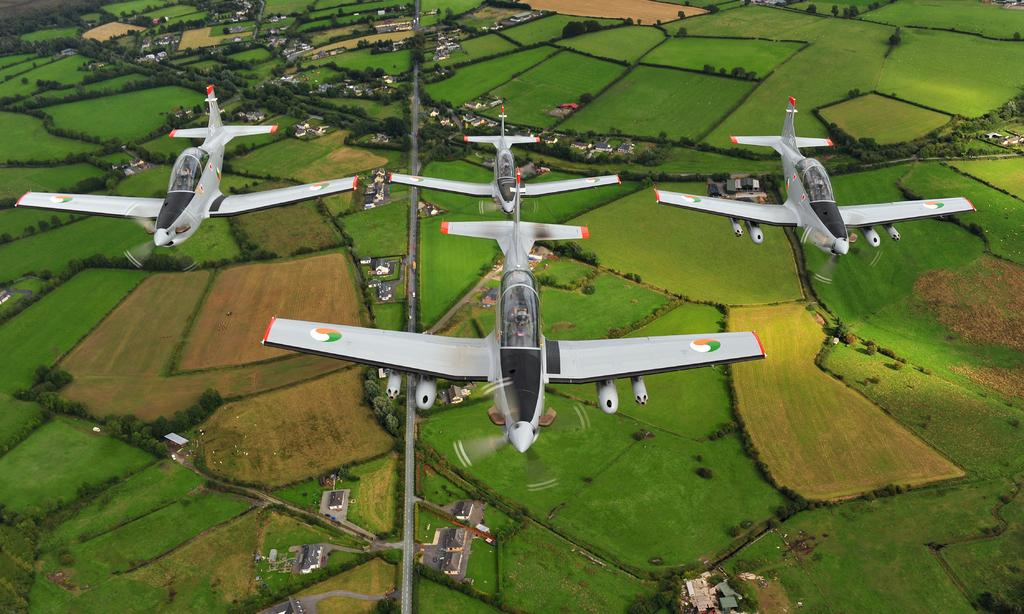What is happening in the sky in the image? There are planes flying in the air in the image. What can be seen on the ground in the image? The ground is visible in the image, along with grass, plants, trees, roads, and houses. Can you describe the natural elements in the image? Grass, plants, and trees are present in the image. What type of man-made structures can be seen in the image? Houses are present in the image. What type of shade is provided by the church in the image? There is no church present in the image, so no shade can be provided by a church. 